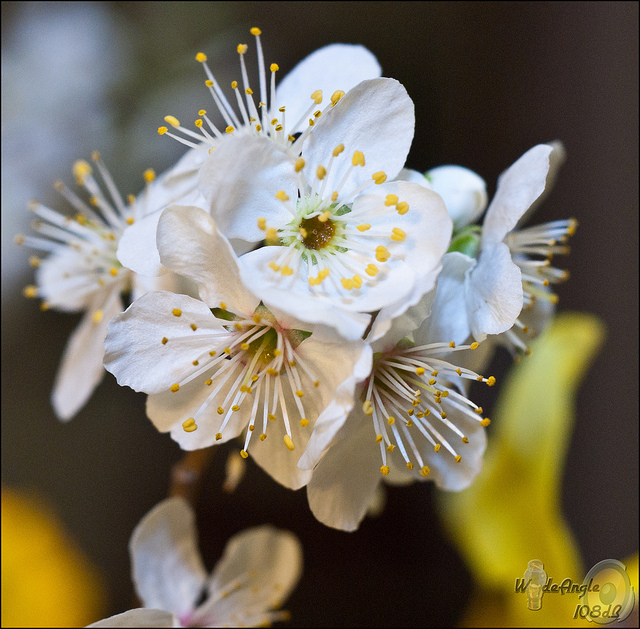Read and extract the text from this image. 108db 